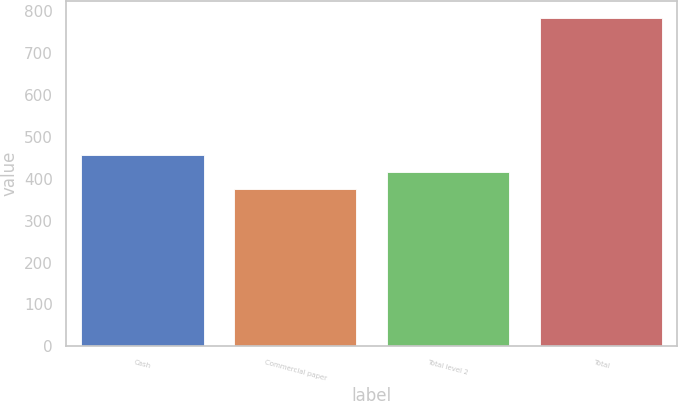<chart> <loc_0><loc_0><loc_500><loc_500><bar_chart><fcel>Cash<fcel>Commercial paper<fcel>Total level 2<fcel>Total<nl><fcel>457.8<fcel>376<fcel>416.9<fcel>785<nl></chart> 